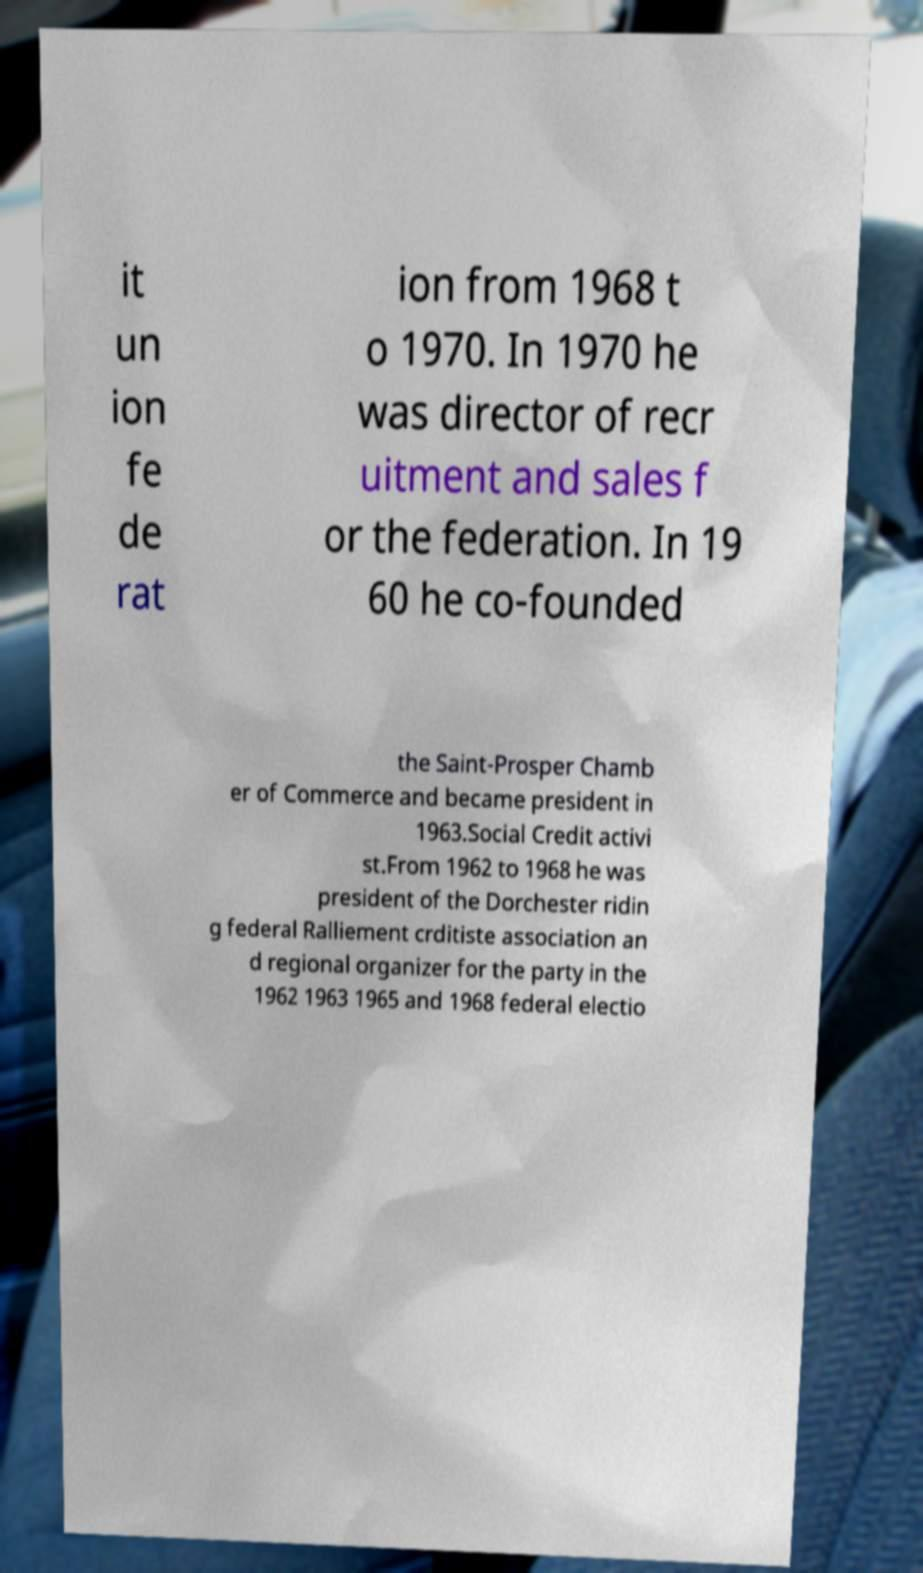There's text embedded in this image that I need extracted. Can you transcribe it verbatim? it un ion fe de rat ion from 1968 t o 1970. In 1970 he was director of recr uitment and sales f or the federation. In 19 60 he co-founded the Saint-Prosper Chamb er of Commerce and became president in 1963.Social Credit activi st.From 1962 to 1968 he was president of the Dorchester ridin g federal Ralliement crditiste association an d regional organizer for the party in the 1962 1963 1965 and 1968 federal electio 